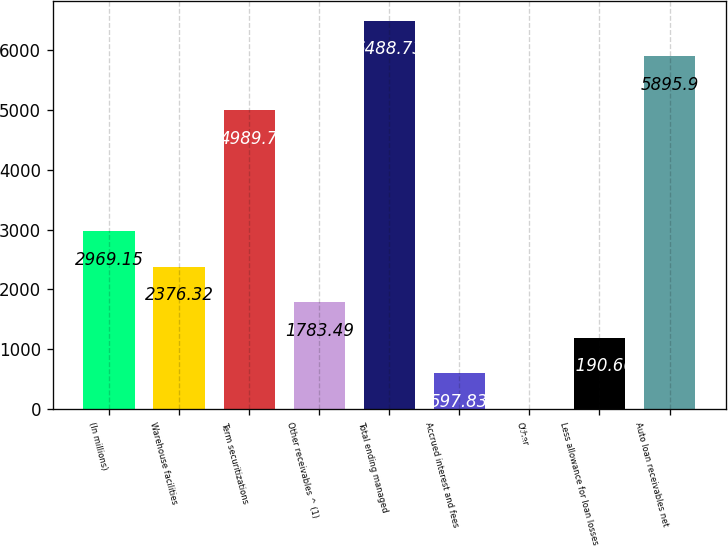<chart> <loc_0><loc_0><loc_500><loc_500><bar_chart><fcel>(In millions)<fcel>Warehouse facilities<fcel>Term securitizations<fcel>Other receivables ^ (1)<fcel>Total ending managed<fcel>Accrued interest and fees<fcel>Other<fcel>Less allowance for loan losses<fcel>Auto loan receivables net<nl><fcel>2969.15<fcel>2376.32<fcel>4989.7<fcel>1783.49<fcel>6488.73<fcel>597.83<fcel>5<fcel>1190.66<fcel>5895.9<nl></chart> 